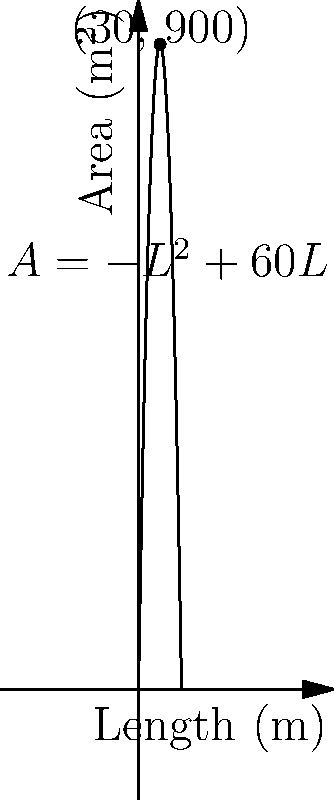A traditional Persian rug manufacturer wants to create a rectangular rug with a perimeter of 120 meters. The area $A$ of the rug is given by the function $A(L) = -L^2 + 60L$, where $L$ is the length of the rug in meters. What dimensions should the rug have to maximize its area, and what is the maximum area? Let's approach this step-by-step:

1) The area function is given as $A(L) = -L^2 + 60L$, where $L$ is the length.

2) To find the maximum area, we need to find the vertex of this parabola. The vertex represents the point where the area is largest.

3) For a quadratic function in the form $f(x) = ax^2 + bx + c$, the x-coordinate of the vertex is given by $x = -\frac{b}{2a}$.

4) In our case, $a = -1$, $b = 60$, and $c = 0$. So:

   $L = -\frac{60}{2(-1)} = 30$ meters

5) This means the length that maximizes the area is 30 meters.

6) To find the width, we can use the fact that the perimeter is 120 meters:
   
   $2L + 2W = 120$
   $2(30) + 2W = 120$
   $60 + 2W = 120$
   $2W = 60$
   $W = 30$ meters

7) The maximum area can be found by plugging $L = 30$ into the original function:

   $A(30) = -(30)^2 + 60(30) = -900 + 1800 = 900$ square meters

Therefore, the rug should be 30 meters long and 30 meters wide to maximize its area, which will be 900 square meters.
Answer: 30m x 30m, 900m² 